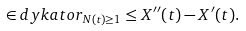<formula> <loc_0><loc_0><loc_500><loc_500>\in d y k a t o r _ { N ( t ) \geq 1 } \leq X ^ { \prime \prime } ( t ) - X ^ { \prime } ( t ) .</formula> 